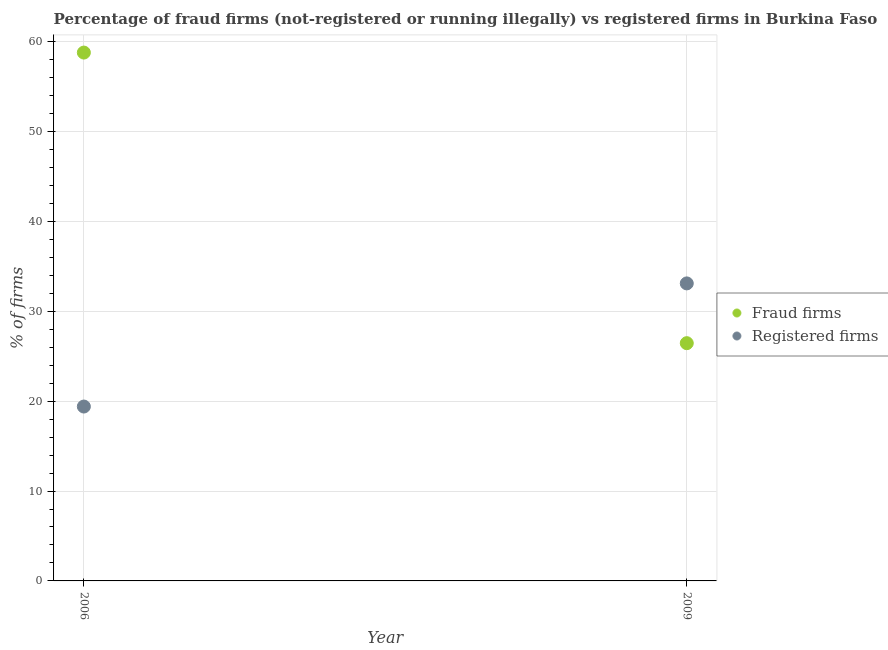How many different coloured dotlines are there?
Ensure brevity in your answer.  2. What is the percentage of fraud firms in 2006?
Your answer should be compact. 58.78. Across all years, what is the maximum percentage of fraud firms?
Offer a terse response. 58.78. In which year was the percentage of fraud firms maximum?
Your response must be concise. 2006. In which year was the percentage of registered firms minimum?
Make the answer very short. 2006. What is the total percentage of fraud firms in the graph?
Offer a terse response. 85.23. What is the difference between the percentage of fraud firms in 2006 and that in 2009?
Your answer should be very brief. 32.33. What is the difference between the percentage of registered firms in 2006 and the percentage of fraud firms in 2009?
Give a very brief answer. -7.05. What is the average percentage of fraud firms per year?
Offer a terse response. 42.62. In the year 2006, what is the difference between the percentage of registered firms and percentage of fraud firms?
Your answer should be very brief. -39.38. What is the ratio of the percentage of registered firms in 2006 to that in 2009?
Provide a succinct answer. 0.59. In how many years, is the percentage of registered firms greater than the average percentage of registered firms taken over all years?
Keep it short and to the point. 1. Does the percentage of registered firms monotonically increase over the years?
Ensure brevity in your answer.  Yes. Is the percentage of fraud firms strictly greater than the percentage of registered firms over the years?
Make the answer very short. No. Is the percentage of fraud firms strictly less than the percentage of registered firms over the years?
Give a very brief answer. No. How many dotlines are there?
Offer a very short reply. 2. How many years are there in the graph?
Offer a very short reply. 2. What is the difference between two consecutive major ticks on the Y-axis?
Provide a short and direct response. 10. How are the legend labels stacked?
Your answer should be compact. Vertical. What is the title of the graph?
Provide a succinct answer. Percentage of fraud firms (not-registered or running illegally) vs registered firms in Burkina Faso. Does "Not attending school" appear as one of the legend labels in the graph?
Provide a succinct answer. No. What is the label or title of the X-axis?
Provide a succinct answer. Year. What is the label or title of the Y-axis?
Give a very brief answer. % of firms. What is the % of firms in Fraud firms in 2006?
Give a very brief answer. 58.78. What is the % of firms of Registered firms in 2006?
Your answer should be compact. 19.4. What is the % of firms of Fraud firms in 2009?
Keep it short and to the point. 26.45. What is the % of firms of Registered firms in 2009?
Give a very brief answer. 33.1. Across all years, what is the maximum % of firms of Fraud firms?
Provide a succinct answer. 58.78. Across all years, what is the maximum % of firms in Registered firms?
Ensure brevity in your answer.  33.1. Across all years, what is the minimum % of firms of Fraud firms?
Provide a short and direct response. 26.45. What is the total % of firms in Fraud firms in the graph?
Offer a very short reply. 85.23. What is the total % of firms of Registered firms in the graph?
Offer a very short reply. 52.5. What is the difference between the % of firms in Fraud firms in 2006 and that in 2009?
Your answer should be compact. 32.33. What is the difference between the % of firms of Registered firms in 2006 and that in 2009?
Provide a short and direct response. -13.7. What is the difference between the % of firms of Fraud firms in 2006 and the % of firms of Registered firms in 2009?
Offer a very short reply. 25.68. What is the average % of firms in Fraud firms per year?
Your answer should be compact. 42.62. What is the average % of firms of Registered firms per year?
Your answer should be compact. 26.25. In the year 2006, what is the difference between the % of firms of Fraud firms and % of firms of Registered firms?
Make the answer very short. 39.38. In the year 2009, what is the difference between the % of firms in Fraud firms and % of firms in Registered firms?
Your answer should be very brief. -6.65. What is the ratio of the % of firms in Fraud firms in 2006 to that in 2009?
Your answer should be very brief. 2.22. What is the ratio of the % of firms of Registered firms in 2006 to that in 2009?
Your answer should be compact. 0.59. What is the difference between the highest and the second highest % of firms in Fraud firms?
Your answer should be compact. 32.33. What is the difference between the highest and the second highest % of firms in Registered firms?
Keep it short and to the point. 13.7. What is the difference between the highest and the lowest % of firms of Fraud firms?
Ensure brevity in your answer.  32.33. 